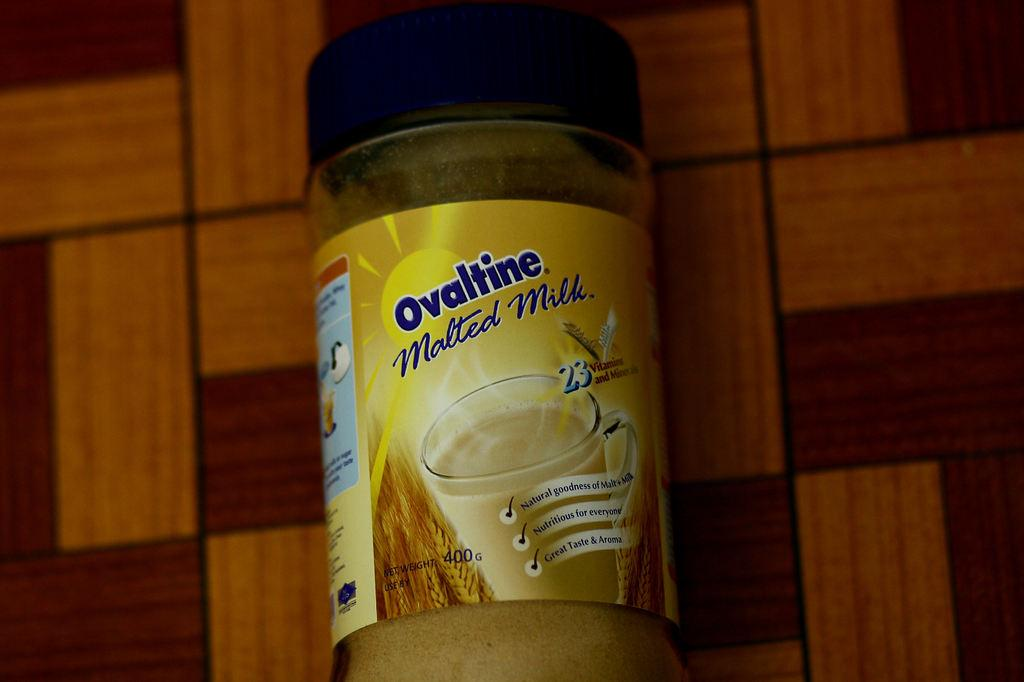<image>
Describe the image concisely. A malted milk mix container placed on a brown surface. 